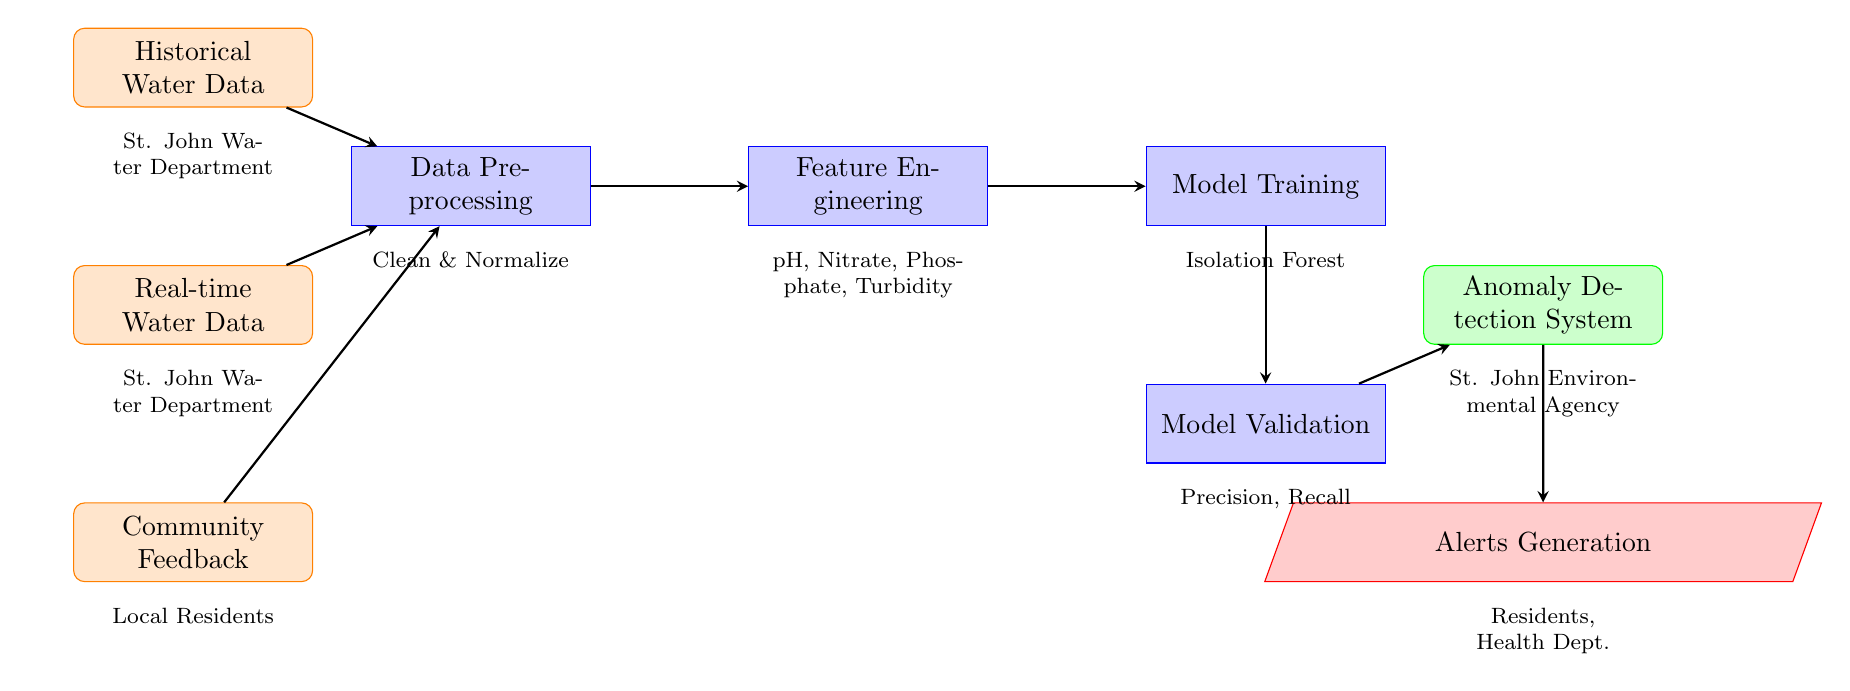What are the types of input used in the anomaly detection system? The diagram shows three types of input: "Historical Water Data," "Real-time Water Data," and "Community Feedback." Each of these inputs is represented as a node, indicating they all feed into the preprocessing stage.
Answer: Historical Water Data, Real-time Water Data, Community Feedback What process comes after feature engineering? The diagram indicates that "Model Training" is the process that follows "Feature Engineering." The connection shows a clear flow from one process to the next in the anomaly detection system.
Answer: Model Training What is the output of the anomaly detection system? According to the diagram, the output is labeled as "Anomaly Detection System." This node summarizes the final result of all the processes leading up to this point.
Answer: Anomaly Detection System Which node generates alerts after the anomaly detection system? The diagram states that "Alerts Generation" is the action that occurs following the output of the anomaly detection system. This shows the direct result and output action stemming from the system’s output.
Answer: Alerts Generation What evaluation metrics are used in model validation? The diagram lists "Precision, Recall" as the metrics used in the "Model Validation" process, indicating the focus on these particular metrics for assessing model performance.
Answer: Precision, Recall How many processing steps are there in total? Following the flow from input to output, there are four processing steps: "Data Preprocessing," "Feature Engineering," "Model Training," and "Model Validation," which can be counted directly in the diagram.
Answer: Four Which entity provides the historical water data? The diagram shows that the "St. John Water Department" is the source for both "Historical Water Data" and "Real-time Water Data," indicating this organization is responsible for the collection of the input data.
Answer: St. John Water Department What role does community feedback play in the system? The diagram illustrates that "Community Feedback" is an input to the "Data Preprocessing" process, indicating that it is collected and used to inform the detection of anomalies in water quality data.
Answer: Input for preprocessing What is the focus of feature engineering in this diagram? The diagram specifies that feature engineering focuses on several key water quality parameters: "pH, Nitrate, Phosphate, Turbidity," which highlights the elements that will be expanded upon in the model.
Answer: pH, Nitrate, Phosphate, Turbidity 